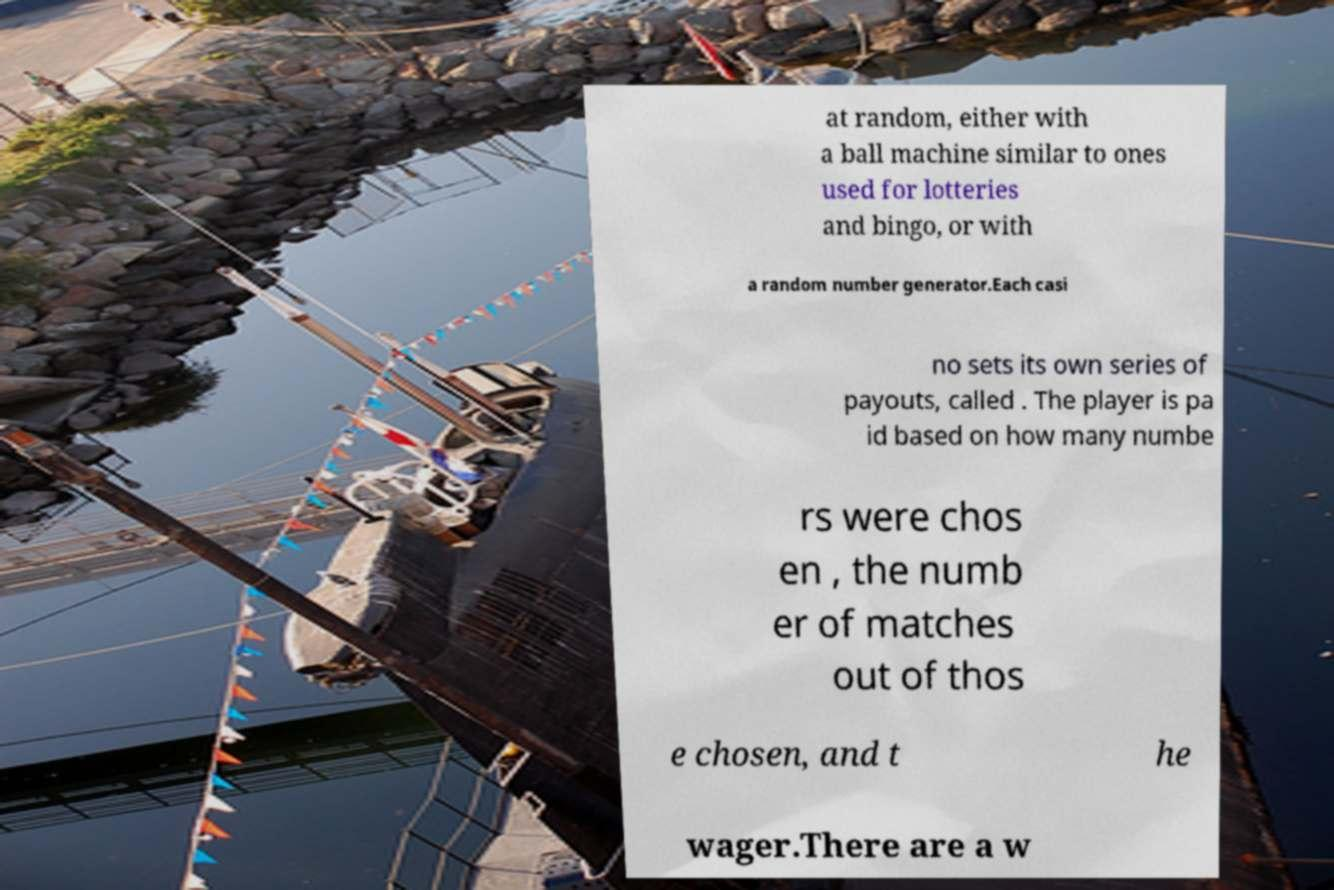There's text embedded in this image that I need extracted. Can you transcribe it verbatim? at random, either with a ball machine similar to ones used for lotteries and bingo, or with a random number generator.Each casi no sets its own series of payouts, called . The player is pa id based on how many numbe rs were chos en , the numb er of matches out of thos e chosen, and t he wager.There are a w 